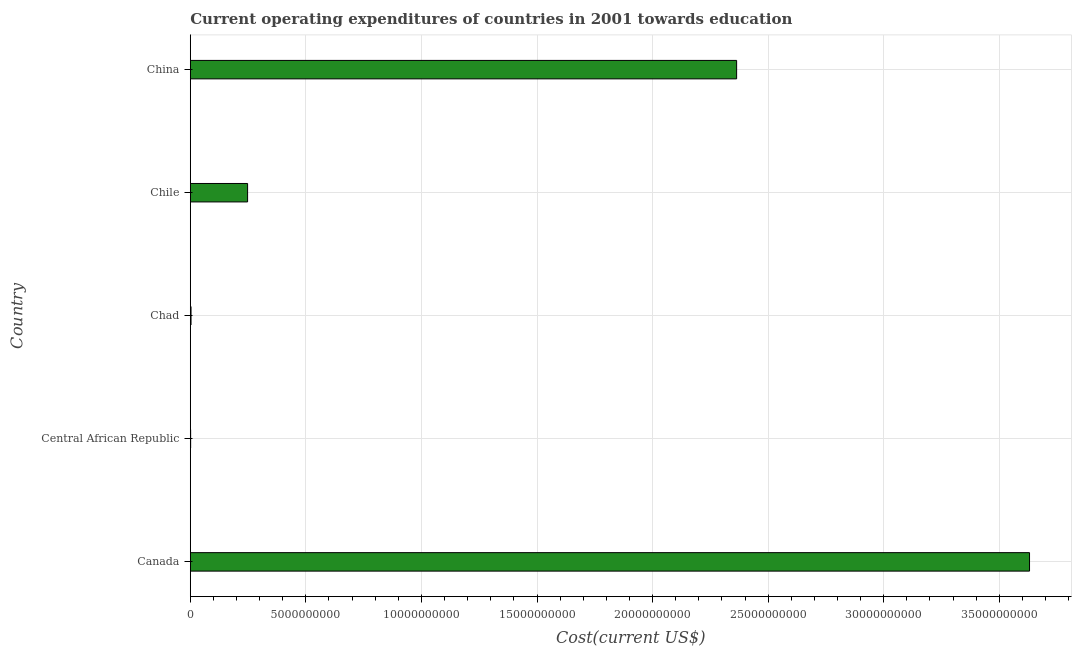Does the graph contain any zero values?
Your answer should be compact. No. What is the title of the graph?
Ensure brevity in your answer.  Current operating expenditures of countries in 2001 towards education. What is the label or title of the X-axis?
Give a very brief answer. Cost(current US$). What is the education expenditure in China?
Your response must be concise. 2.36e+1. Across all countries, what is the maximum education expenditure?
Provide a short and direct response. 3.63e+1. Across all countries, what is the minimum education expenditure?
Ensure brevity in your answer.  1.48e+07. In which country was the education expenditure minimum?
Give a very brief answer. Central African Republic. What is the sum of the education expenditure?
Keep it short and to the point. 6.25e+1. What is the difference between the education expenditure in Canada and Chad?
Provide a short and direct response. 3.63e+1. What is the average education expenditure per country?
Your answer should be very brief. 1.25e+1. What is the median education expenditure?
Give a very brief answer. 2.48e+09. In how many countries, is the education expenditure greater than 17000000000 US$?
Provide a short and direct response. 2. What is the ratio of the education expenditure in Canada to that in Chad?
Keep it short and to the point. 1132.85. What is the difference between the highest and the second highest education expenditure?
Keep it short and to the point. 1.27e+1. What is the difference between the highest and the lowest education expenditure?
Ensure brevity in your answer.  3.63e+1. In how many countries, is the education expenditure greater than the average education expenditure taken over all countries?
Offer a very short reply. 2. How many countries are there in the graph?
Your response must be concise. 5. What is the difference between two consecutive major ticks on the X-axis?
Ensure brevity in your answer.  5.00e+09. Are the values on the major ticks of X-axis written in scientific E-notation?
Provide a succinct answer. No. What is the Cost(current US$) in Canada?
Make the answer very short. 3.63e+1. What is the Cost(current US$) in Central African Republic?
Provide a short and direct response. 1.48e+07. What is the Cost(current US$) in Chad?
Provide a succinct answer. 3.20e+07. What is the Cost(current US$) in Chile?
Make the answer very short. 2.48e+09. What is the Cost(current US$) in China?
Your response must be concise. 2.36e+1. What is the difference between the Cost(current US$) in Canada and Central African Republic?
Offer a very short reply. 3.63e+1. What is the difference between the Cost(current US$) in Canada and Chad?
Ensure brevity in your answer.  3.63e+1. What is the difference between the Cost(current US$) in Canada and Chile?
Offer a very short reply. 3.38e+1. What is the difference between the Cost(current US$) in Canada and China?
Offer a very short reply. 1.27e+1. What is the difference between the Cost(current US$) in Central African Republic and Chad?
Your answer should be compact. -1.73e+07. What is the difference between the Cost(current US$) in Central African Republic and Chile?
Make the answer very short. -2.46e+09. What is the difference between the Cost(current US$) in Central African Republic and China?
Your answer should be compact. -2.36e+1. What is the difference between the Cost(current US$) in Chad and Chile?
Ensure brevity in your answer.  -2.45e+09. What is the difference between the Cost(current US$) in Chad and China?
Provide a succinct answer. -2.36e+1. What is the difference between the Cost(current US$) in Chile and China?
Make the answer very short. -2.12e+1. What is the ratio of the Cost(current US$) in Canada to that in Central African Republic?
Offer a very short reply. 2455.82. What is the ratio of the Cost(current US$) in Canada to that in Chad?
Ensure brevity in your answer.  1132.85. What is the ratio of the Cost(current US$) in Canada to that in Chile?
Ensure brevity in your answer.  14.64. What is the ratio of the Cost(current US$) in Canada to that in China?
Make the answer very short. 1.54. What is the ratio of the Cost(current US$) in Central African Republic to that in Chad?
Ensure brevity in your answer.  0.46. What is the ratio of the Cost(current US$) in Central African Republic to that in Chile?
Give a very brief answer. 0.01. What is the ratio of the Cost(current US$) in Chad to that in Chile?
Make the answer very short. 0.01. What is the ratio of the Cost(current US$) in Chad to that in China?
Keep it short and to the point. 0. What is the ratio of the Cost(current US$) in Chile to that in China?
Ensure brevity in your answer.  0.1. 